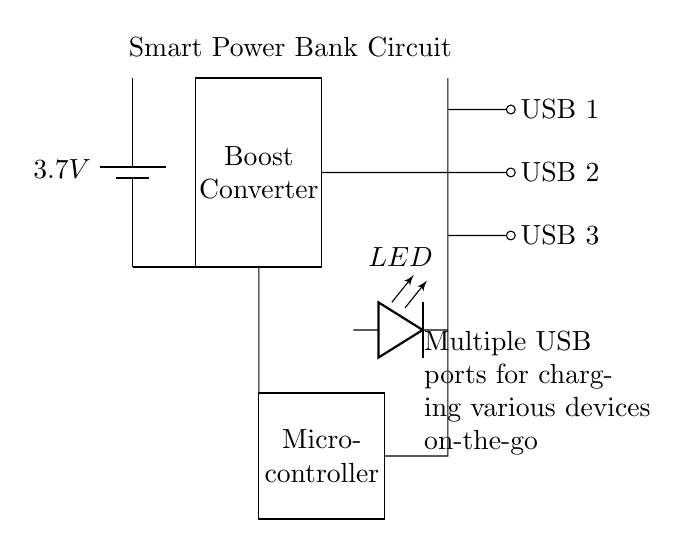What is the voltage of the battery? The battery in the circuit is labeled with a voltage of 3.7V, indicating the potential difference it provides.
Answer: 3.7V What type of component is the boost converter? The boost converter is represented as a rectangle in the circuit and is labeled as "Boost Converter," indicating its function in stepping up the voltage from the battery.
Answer: Boost Converter How many USB ports are available in this circuit? The diagram shows three USB ports, each labeled as USB 1, USB 2, and USB 3, indicating multiple connections for charging devices.
Answer: Three What is the role of the microcontroller? The microcontroller, indicated as a rectangle labeled "Microcontroller," is responsible for managing the power distribution to the USB ports and controlling the overall operation of the circuit.
Answer: Management Where is the LED indicator placed in the circuit? The LED indicator is located between the boost converter and the USB ports, reflecting the operational status of the power bank, specifically at coordinates (3.5, -1) to (5, -1).
Answer: Between boost converter and USB ports Which components are directly connected to the battery? The battery is directly connected to the boost converter and subsequently to the microcontroller, and it illustrates how the circuit starts from the power source.
Answer: Boost converter, microcontroller What does the term "multiple devices on-the-go" imply in relation to this circuit? This term suggests the circuit is designed to charge various devices simultaneously through the multiple USB ports available, indicating portability and convenience.
Answer: Charging multiple devices 